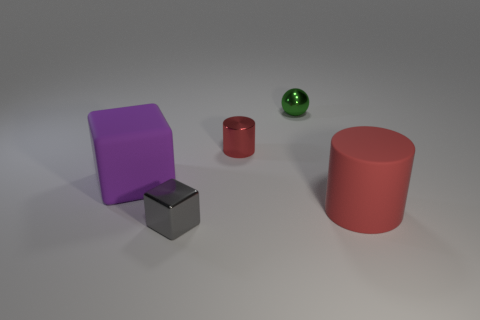How big is the object that is in front of the big purple rubber object and left of the red metallic cylinder?
Ensure brevity in your answer.  Small. The metal thing that is the same shape as the red matte object is what size?
Keep it short and to the point. Small. There is a red rubber cylinder; are there any big purple rubber things on the left side of it?
Offer a very short reply. Yes. What is the gray object made of?
Offer a very short reply. Metal. There is a cube in front of the big rubber cylinder; is its color the same as the tiny sphere?
Offer a very short reply. No. Is there any other thing that has the same shape as the tiny green metal thing?
Offer a terse response. No. There is another shiny thing that is the same shape as the large purple object; what color is it?
Offer a very short reply. Gray. What is the thing on the left side of the metallic block made of?
Your answer should be compact. Rubber. The rubber cube has what color?
Offer a very short reply. Purple. There is a matte thing to the left of the green metal ball; does it have the same size as the red rubber cylinder?
Provide a succinct answer. Yes. 